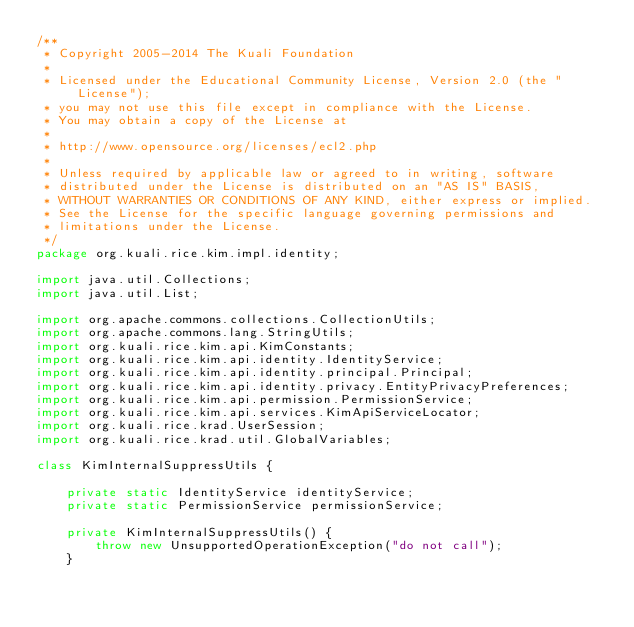Convert code to text. <code><loc_0><loc_0><loc_500><loc_500><_Java_>/**
 * Copyright 2005-2014 The Kuali Foundation
 *
 * Licensed under the Educational Community License, Version 2.0 (the "License");
 * you may not use this file except in compliance with the License.
 * You may obtain a copy of the License at
 *
 * http://www.opensource.org/licenses/ecl2.php
 *
 * Unless required by applicable law or agreed to in writing, software
 * distributed under the License is distributed on an "AS IS" BASIS,
 * WITHOUT WARRANTIES OR CONDITIONS OF ANY KIND, either express or implied.
 * See the License for the specific language governing permissions and
 * limitations under the License.
 */
package org.kuali.rice.kim.impl.identity;

import java.util.Collections;
import java.util.List;

import org.apache.commons.collections.CollectionUtils;
import org.apache.commons.lang.StringUtils;
import org.kuali.rice.kim.api.KimConstants;
import org.kuali.rice.kim.api.identity.IdentityService;
import org.kuali.rice.kim.api.identity.principal.Principal;
import org.kuali.rice.kim.api.identity.privacy.EntityPrivacyPreferences;
import org.kuali.rice.kim.api.permission.PermissionService;
import org.kuali.rice.kim.api.services.KimApiServiceLocator;
import org.kuali.rice.krad.UserSession;
import org.kuali.rice.krad.util.GlobalVariables;

class KimInternalSuppressUtils {

    private static IdentityService identityService;
    private static PermissionService permissionService;

	private KimInternalSuppressUtils() {
		throw new UnsupportedOperationException("do not call");
	}
</code> 